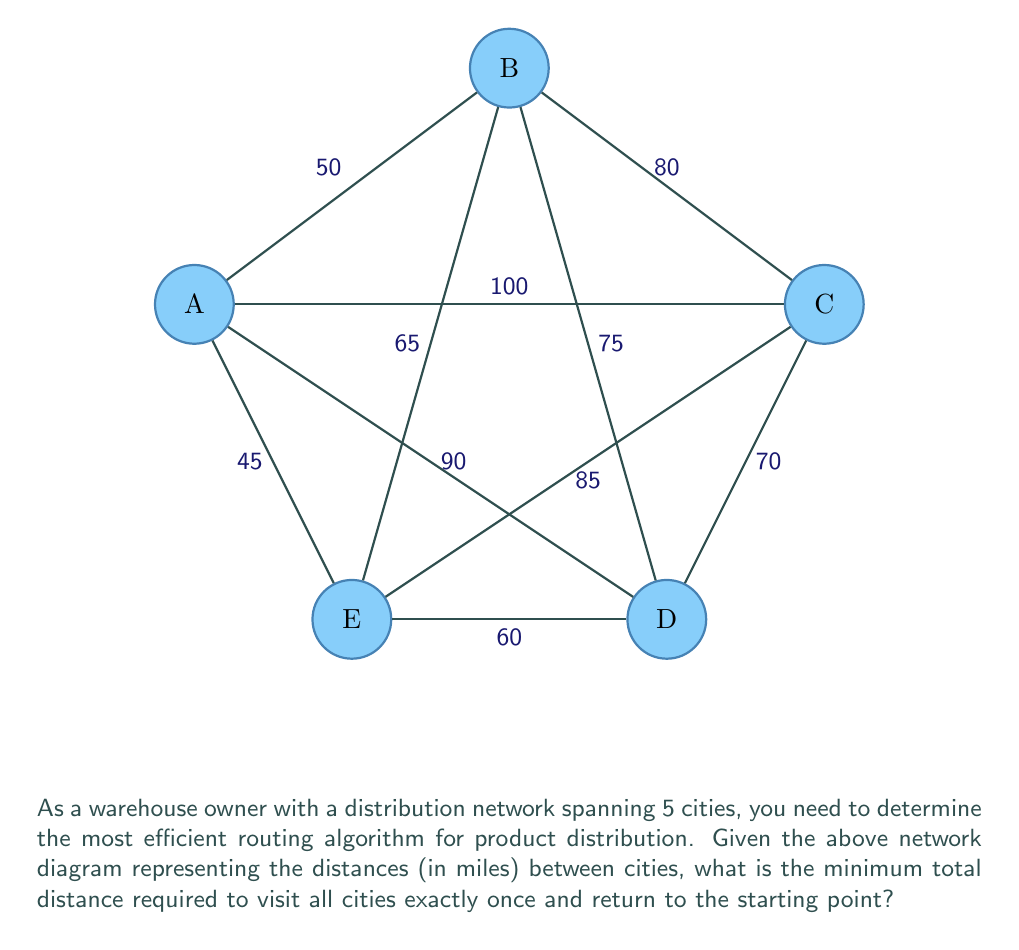Provide a solution to this math problem. This problem is an instance of the Traveling Salesman Problem (TSP), which aims to find the shortest possible route that visits each city exactly once and returns to the starting point. For a small number of cities like in this case, we can solve it using the following steps:

1) First, we need to list all possible routes. With 5 cities, there are $(5-1)! = 24$ possible routes (we fix the starting city).

2) For each route, calculate the total distance:

   For example, let's calculate the distance for route A-B-C-D-E-A:
   $$ d_{A-B-C-D-E-A} = 50 + 80 + 70 + 60 + 45 = 305 \text{ miles} $$

3) We need to do this for all 24 routes. Some of the routes are:

   A-B-C-D-E-A: 305 miles
   A-B-C-E-D-A: 320 miles
   A-B-D-C-E-A: 300 miles
   A-B-D-E-C-A: 310 miles
   A-B-E-C-D-A: 330 miles
   ...

4) After calculating all routes, we find that the shortest route is:

   A-E-D-C-B-A with a total distance of 290 miles

This route can be verified:
$$ d_{A-E-D-C-B-A} = 45 + 60 + 70 + 80 + 50 = 290 \text{ miles} $$

5) Therefore, the minimum total distance required to visit all cities exactly once and return to the starting point is 290 miles.

This brute-force method works for small networks, but for larger networks, more sophisticated algorithms like the Lin-Kernighan heuristic or genetic algorithms are needed due to the NP-hardness of the TSP.
Answer: 290 miles 